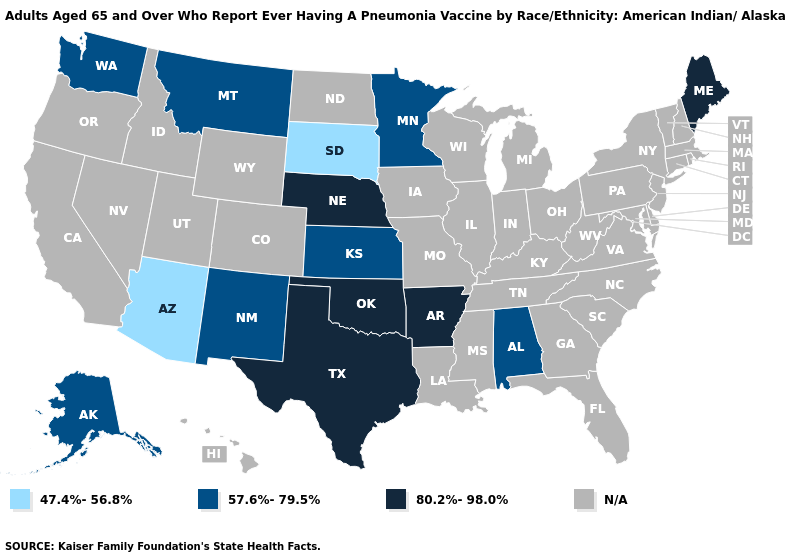Does the first symbol in the legend represent the smallest category?
Be succinct. Yes. What is the lowest value in states that border Minnesota?
Be succinct. 47.4%-56.8%. Does South Dakota have the lowest value in the USA?
Answer briefly. Yes. What is the value of Missouri?
Give a very brief answer. N/A. What is the value of Utah?
Concise answer only. N/A. What is the highest value in the West ?
Short answer required. 57.6%-79.5%. Which states have the lowest value in the USA?
Write a very short answer. Arizona, South Dakota. Name the states that have a value in the range 57.6%-79.5%?
Short answer required. Alabama, Alaska, Kansas, Minnesota, Montana, New Mexico, Washington. What is the value of Colorado?
Quick response, please. N/A. Does Arizona have the highest value in the West?
Keep it brief. No. Which states have the lowest value in the MidWest?
Concise answer only. South Dakota. Name the states that have a value in the range 80.2%-98.0%?
Give a very brief answer. Arkansas, Maine, Nebraska, Oklahoma, Texas. 